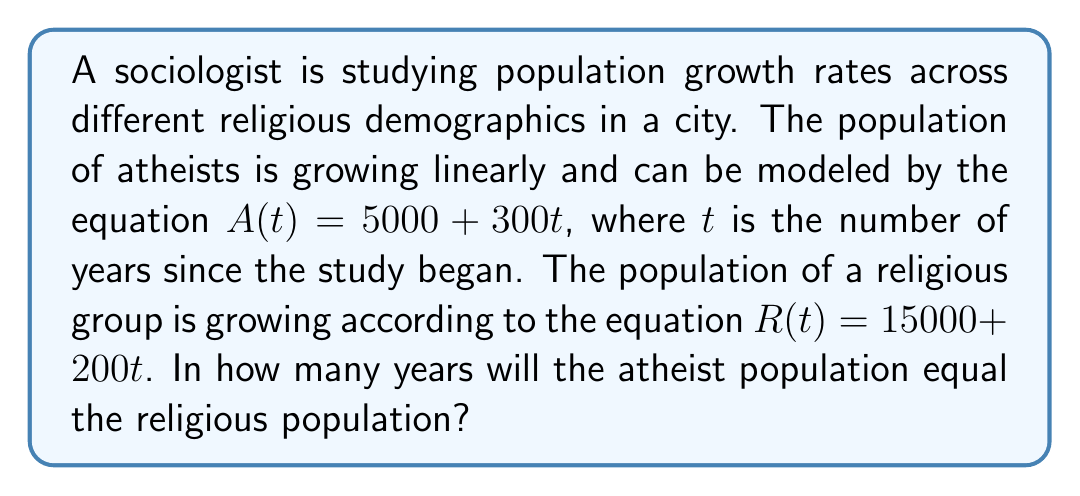Could you help me with this problem? To solve this problem, we need to find the point where the two population equations intersect. This means setting the two equations equal to each other and solving for $t$.

1) Set the equations equal:
   $$5000 + 300t = 15000 + 200t$$

2) Subtract 5000 from both sides:
   $$300t = 10000 + 200t$$

3) Subtract 200t from both sides:
   $$100t = 10000$$

4) Divide both sides by 100:
   $$t = 100$$

5) Check the solution:
   For $t = 100$:
   $A(100) = 5000 + 300(100) = 35000$
   $R(100) = 15000 + 200(100) = 35000$

Therefore, after 100 years, both populations will be equal at 35,000.

This problem demonstrates how linear equations can be used to model and compare population growth rates, which is relevant to sociological studies of demographic changes, particularly in the context of religious and non-religious groups.
Answer: The atheist population will equal the religious population after 100 years. 